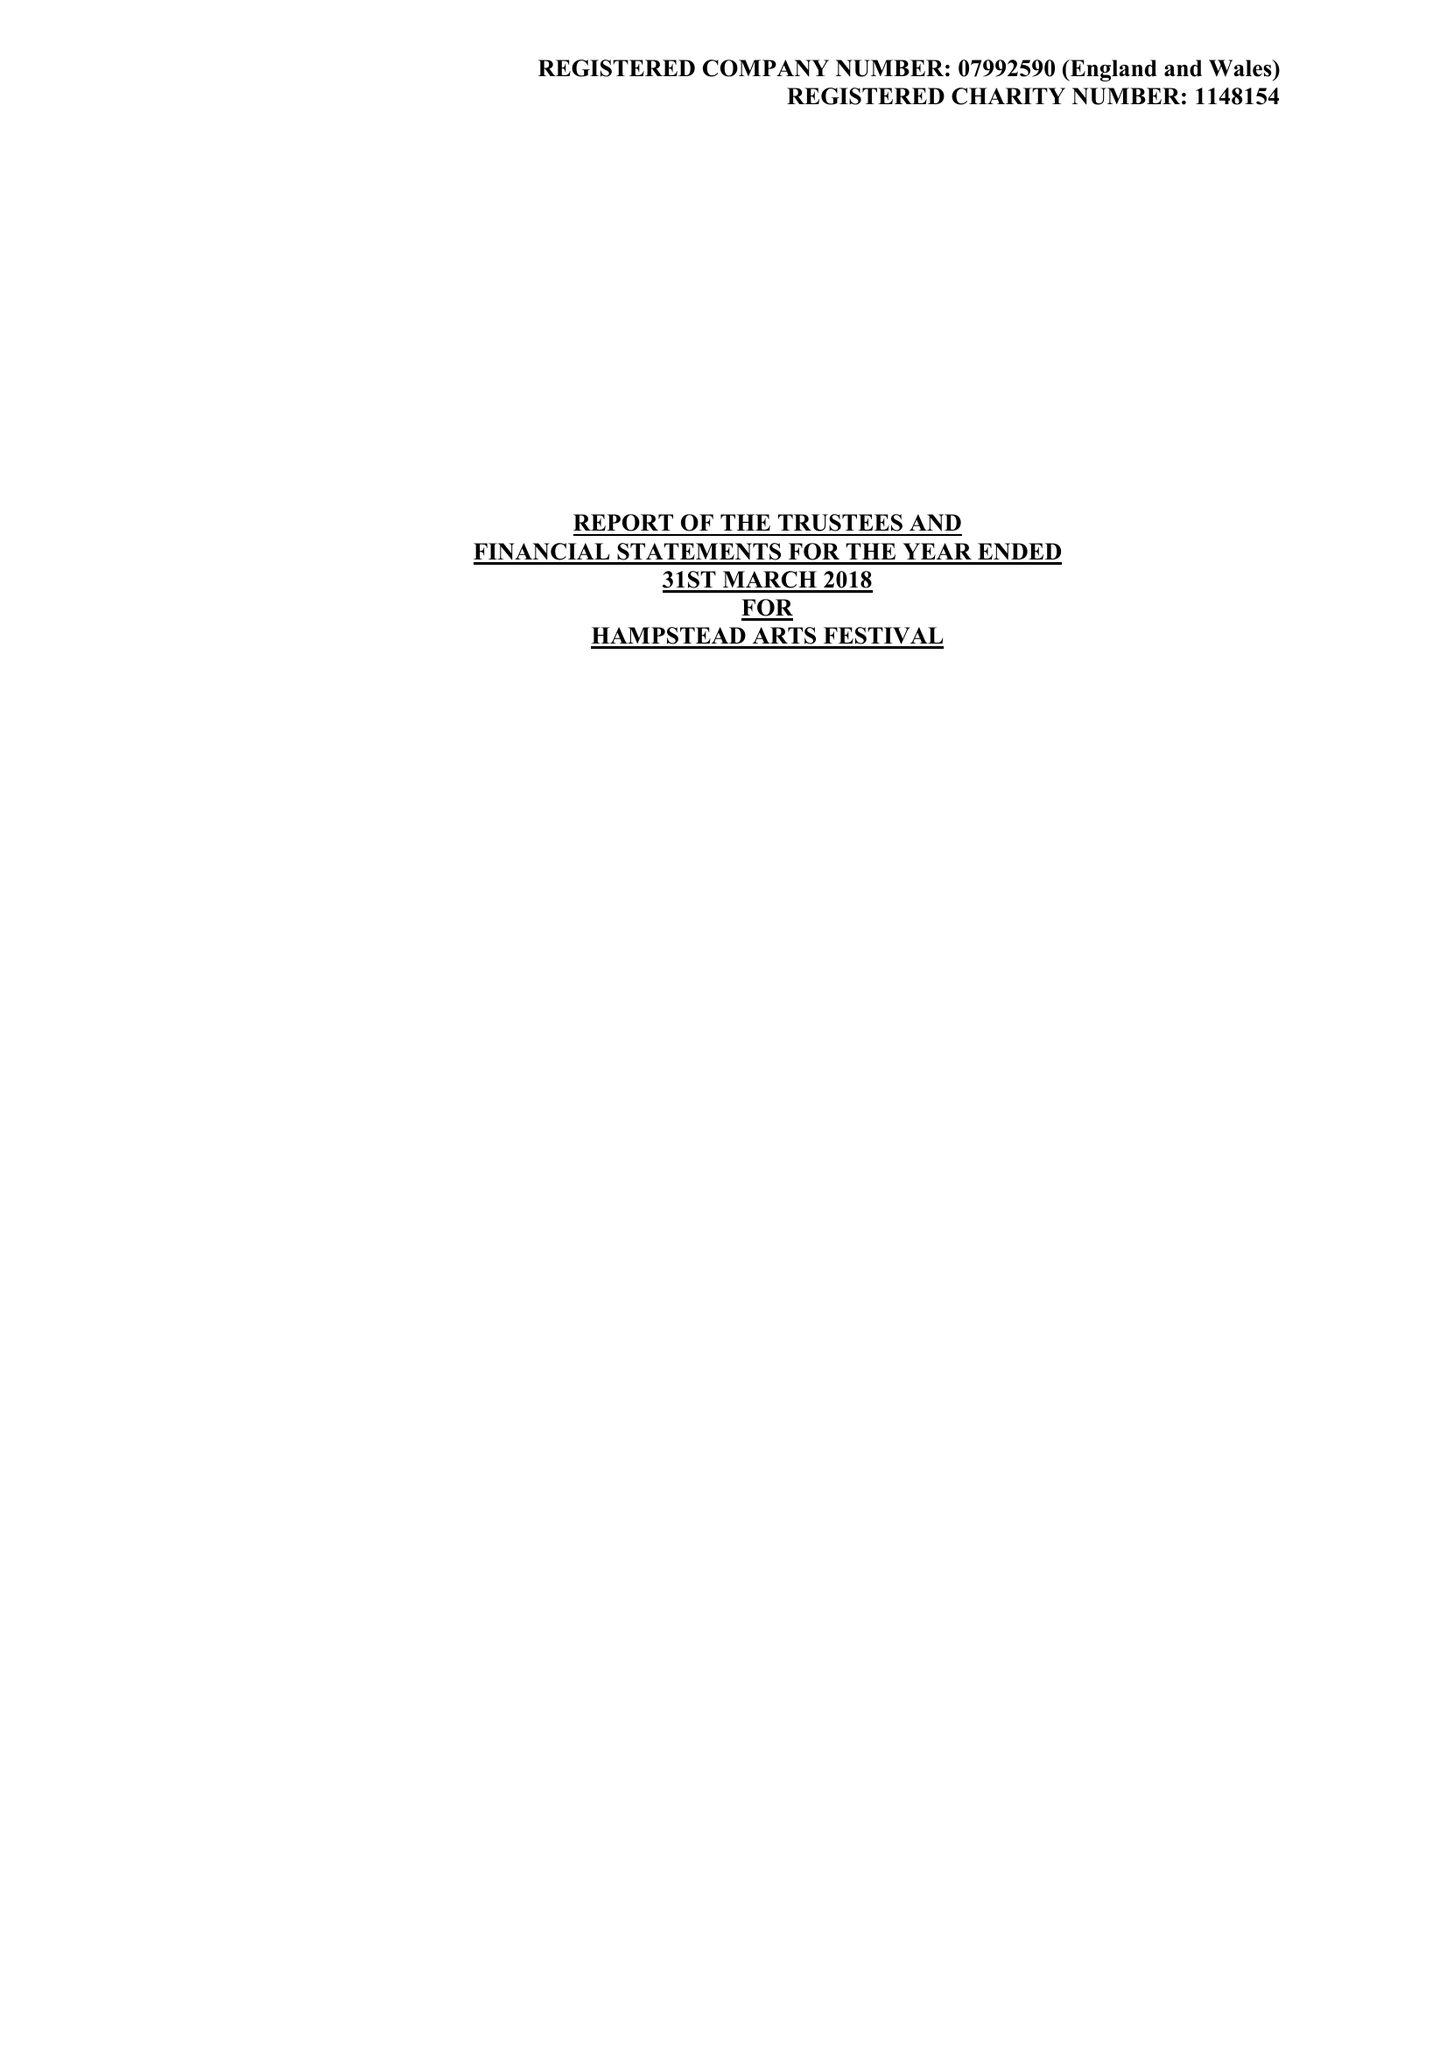What is the value for the address__postcode?
Answer the question using a single word or phrase. HA1 1EJ 